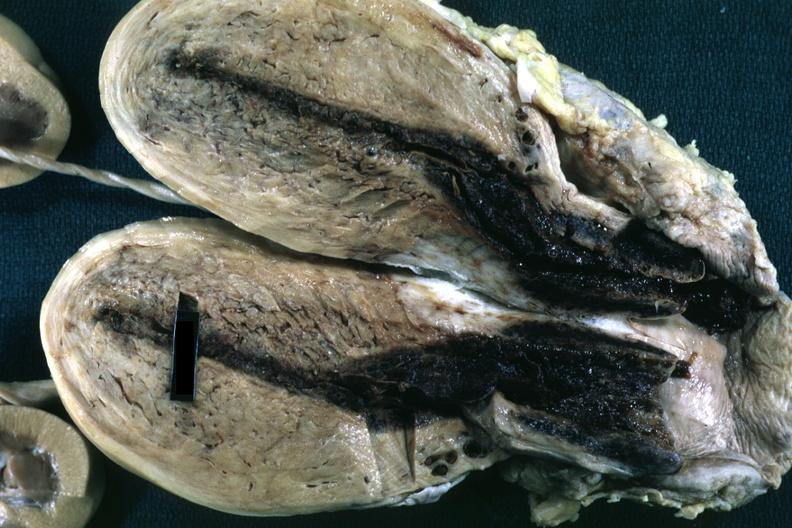how is fixed tissue opened uterus with blood clot in cervical canal and endometrial cavity?
Answer the question using a single word or phrase. Small 